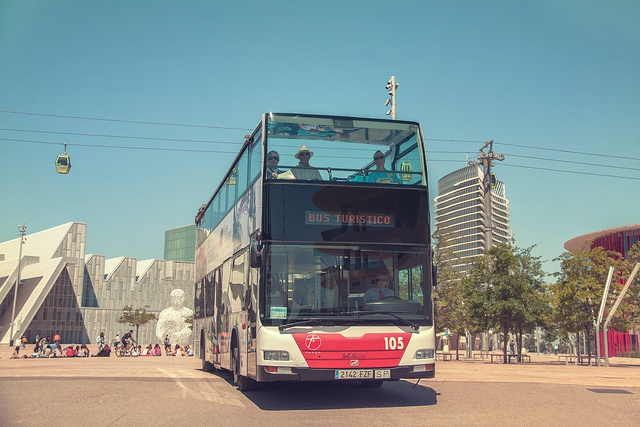Describe the objects in this image and their specific colors. I can see bus in teal, gray, and black tones, people in teal, gray, blue, lightblue, and darkblue tones, people in teal and gray tones, people in teal, gray, black, and blue tones, and people in teal, gray, blue, and darkblue tones in this image. 